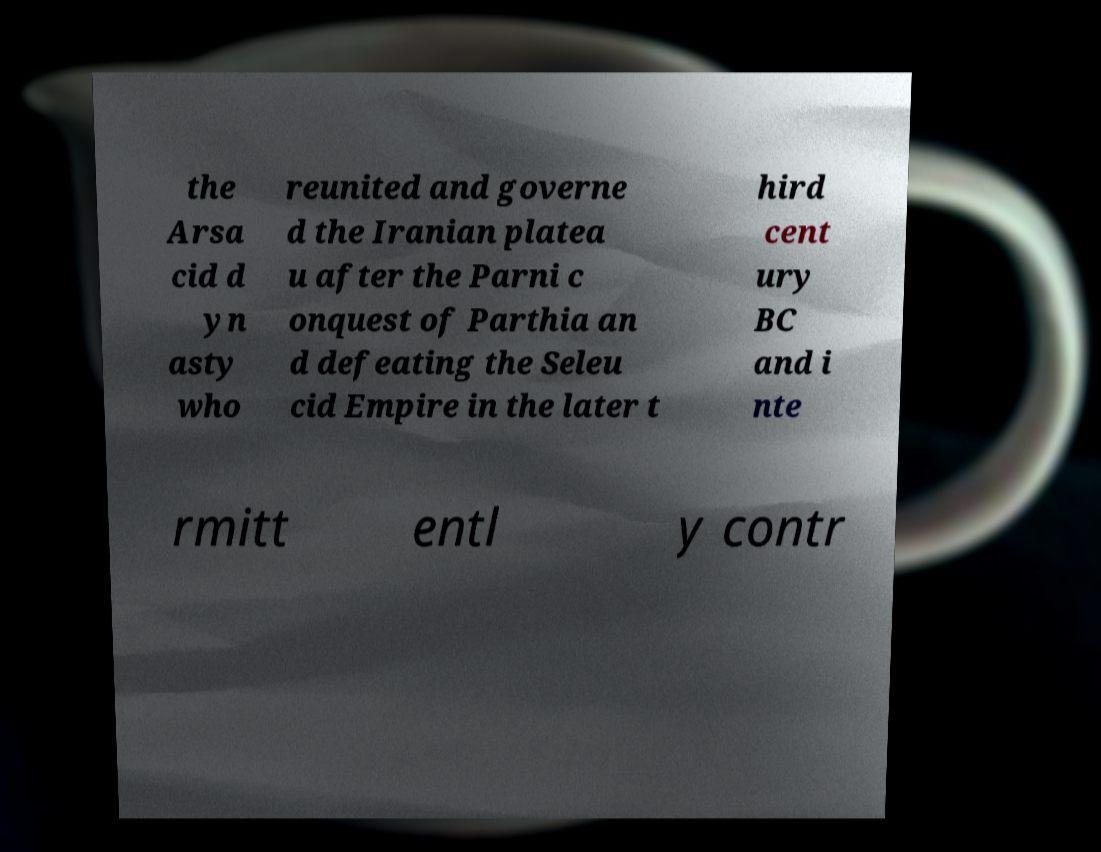Can you accurately transcribe the text from the provided image for me? the Arsa cid d yn asty who reunited and governe d the Iranian platea u after the Parni c onquest of Parthia an d defeating the Seleu cid Empire in the later t hird cent ury BC and i nte rmitt entl y contr 